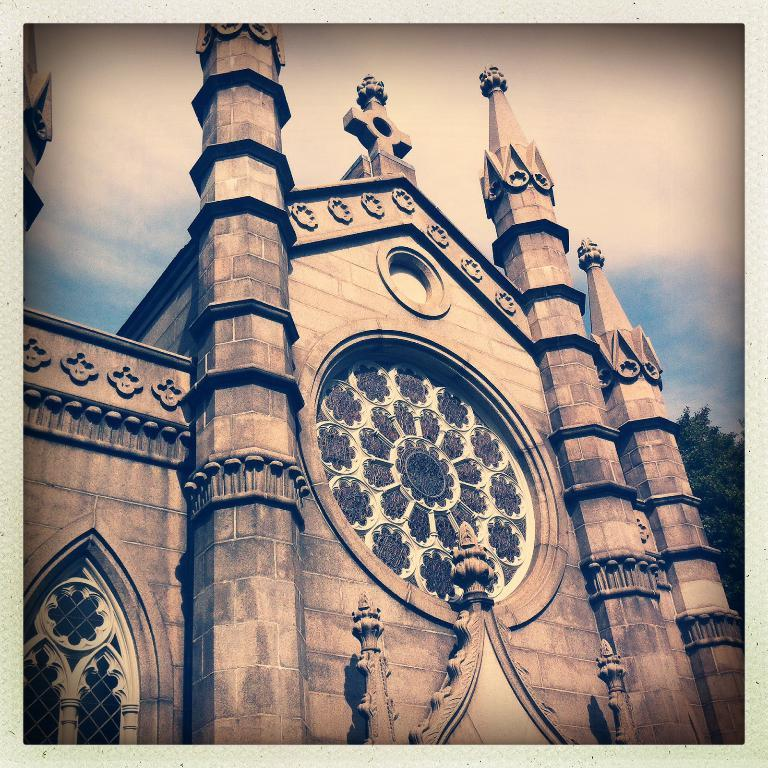What type of structure is visible in the image? There is a building in the image. What type of vegetation can be seen in the image? There are green leaves in the image. What is visible in the background of the image? The sky is visible in the background of the image. What can be observed in the sky? Clouds are present in the sky. How many geese are flying over the building in the image? There are no geese present in the image; it only features a building, green leaves, and a sky with clouds. Is there a zoo visible in the image? There is no zoo present in the image. 